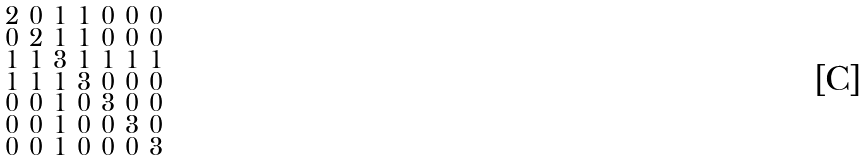<formula> <loc_0><loc_0><loc_500><loc_500>\begin{smallmatrix} 2 & 0 & 1 & 1 & 0 & 0 & 0 \\ 0 & 2 & 1 & 1 & 0 & 0 & 0 \\ 1 & 1 & 3 & 1 & 1 & 1 & 1 \\ 1 & 1 & 1 & 3 & 0 & 0 & 0 \\ 0 & 0 & 1 & 0 & 3 & 0 & 0 \\ 0 & 0 & 1 & 0 & 0 & 3 & 0 \\ 0 & 0 & 1 & 0 & 0 & 0 & 3 \end{smallmatrix}</formula> 